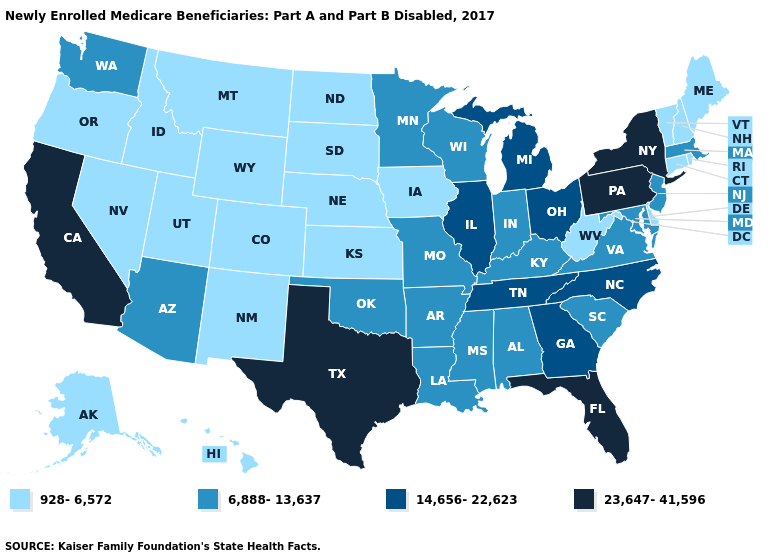Name the states that have a value in the range 6,888-13,637?
Answer briefly. Alabama, Arizona, Arkansas, Indiana, Kentucky, Louisiana, Maryland, Massachusetts, Minnesota, Mississippi, Missouri, New Jersey, Oklahoma, South Carolina, Virginia, Washington, Wisconsin. Does Colorado have the highest value in the West?
Give a very brief answer. No. Name the states that have a value in the range 928-6,572?
Concise answer only. Alaska, Colorado, Connecticut, Delaware, Hawaii, Idaho, Iowa, Kansas, Maine, Montana, Nebraska, Nevada, New Hampshire, New Mexico, North Dakota, Oregon, Rhode Island, South Dakota, Utah, Vermont, West Virginia, Wyoming. Does New York have the highest value in the USA?
Answer briefly. Yes. What is the lowest value in the MidWest?
Answer briefly. 928-6,572. Among the states that border South Carolina , which have the highest value?
Quick response, please. Georgia, North Carolina. Name the states that have a value in the range 23,647-41,596?
Be succinct. California, Florida, New York, Pennsylvania, Texas. What is the highest value in the USA?
Be succinct. 23,647-41,596. Does Tennessee have a lower value than New Mexico?
Concise answer only. No. Does New Hampshire have the lowest value in the USA?
Quick response, please. Yes. Does the map have missing data?
Be succinct. No. Name the states that have a value in the range 6,888-13,637?
Keep it brief. Alabama, Arizona, Arkansas, Indiana, Kentucky, Louisiana, Maryland, Massachusetts, Minnesota, Mississippi, Missouri, New Jersey, Oklahoma, South Carolina, Virginia, Washington, Wisconsin. What is the value of Texas?
Short answer required. 23,647-41,596. Does the first symbol in the legend represent the smallest category?
Keep it brief. Yes. Does the first symbol in the legend represent the smallest category?
Short answer required. Yes. 